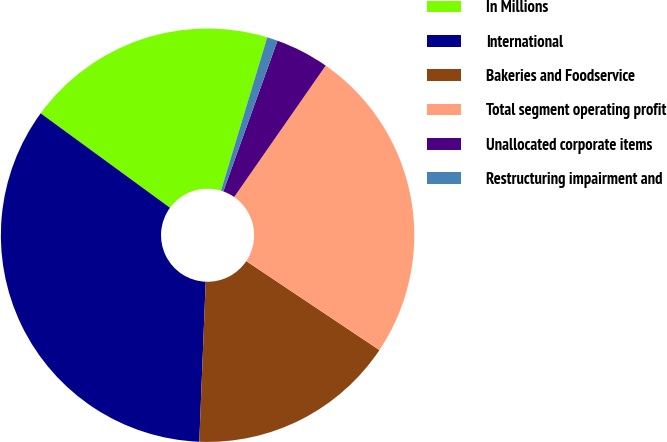Convert chart. <chart><loc_0><loc_0><loc_500><loc_500><pie_chart><fcel>In Millions<fcel>International<fcel>Bakeries and Foodservice<fcel>Total segment operating profit<fcel>Unallocated corporate items<fcel>Restructuring impairment and<nl><fcel>19.62%<fcel>34.4%<fcel>16.26%<fcel>24.7%<fcel>4.19%<fcel>0.83%<nl></chart> 